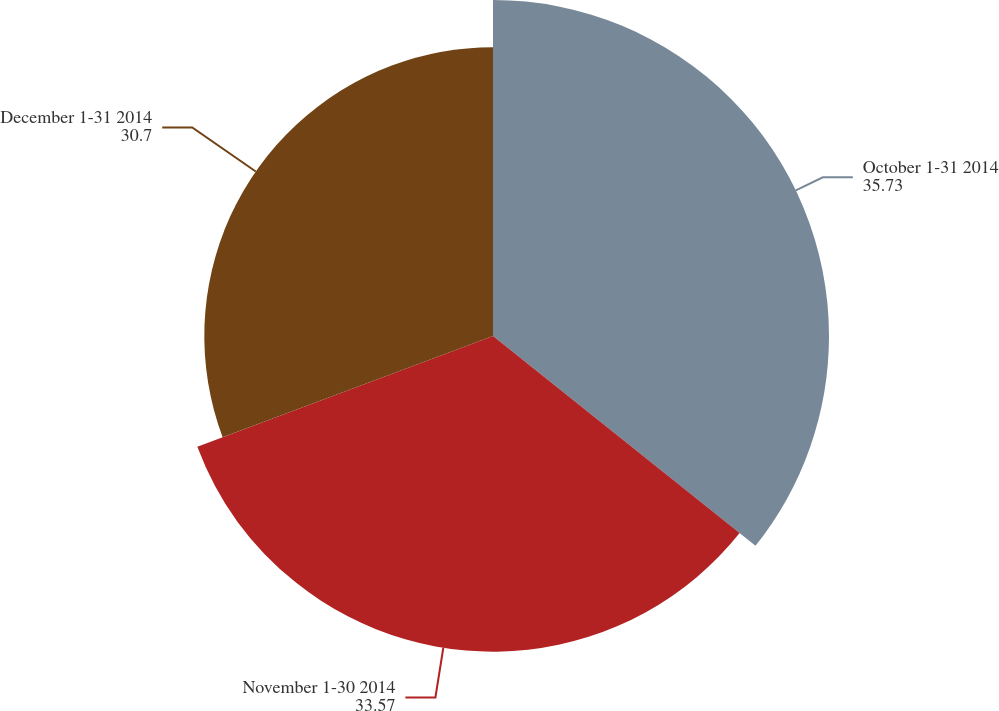<chart> <loc_0><loc_0><loc_500><loc_500><pie_chart><fcel>October 1-31 2014<fcel>November 1-30 2014<fcel>December 1-31 2014<nl><fcel>35.73%<fcel>33.57%<fcel>30.7%<nl></chart> 